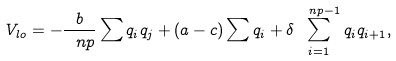<formula> <loc_0><loc_0><loc_500><loc_500>V _ { l o } = - \frac { b } { \ n p } \sum q _ { i } q _ { j } + ( a - c ) \sum q _ { i } + \delta \sum _ { i = 1 } ^ { \ n p - 1 } q _ { i } q _ { i + 1 } ,</formula> 